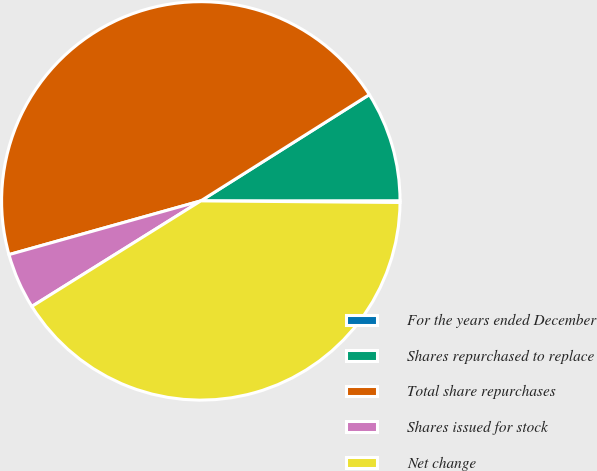Convert chart. <chart><loc_0><loc_0><loc_500><loc_500><pie_chart><fcel>For the years ended December<fcel>Shares repurchased to replace<fcel>Total share repurchases<fcel>Shares issued for stock<fcel>Net change<nl><fcel>0.14%<fcel>8.94%<fcel>45.39%<fcel>4.54%<fcel>40.98%<nl></chart> 